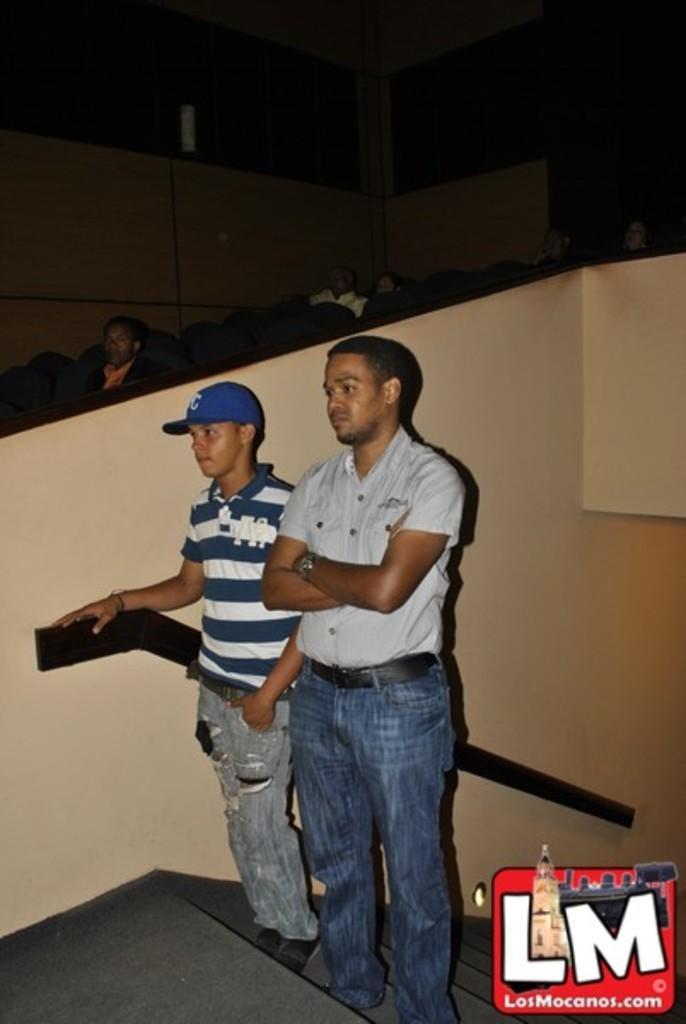Please provide a concise description of this image. In this image I can see two men are standing, I can see one of them is wearing blue colour cap. I can also see stairs, watermark, number of chairs and I can see few people are sitting on chairs. 